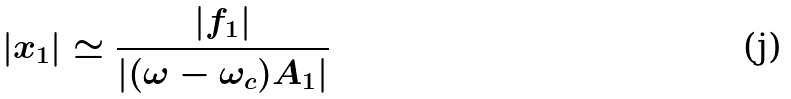Convert formula to latex. <formula><loc_0><loc_0><loc_500><loc_500>| x _ { 1 } | \simeq \frac { | f _ { 1 } | } { | ( \omega - \omega _ { c } ) A _ { 1 } | }</formula> 